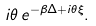<formula> <loc_0><loc_0><loc_500><loc_500>i \theta \, e ^ { - \beta \Delta + i \theta \xi } .</formula> 